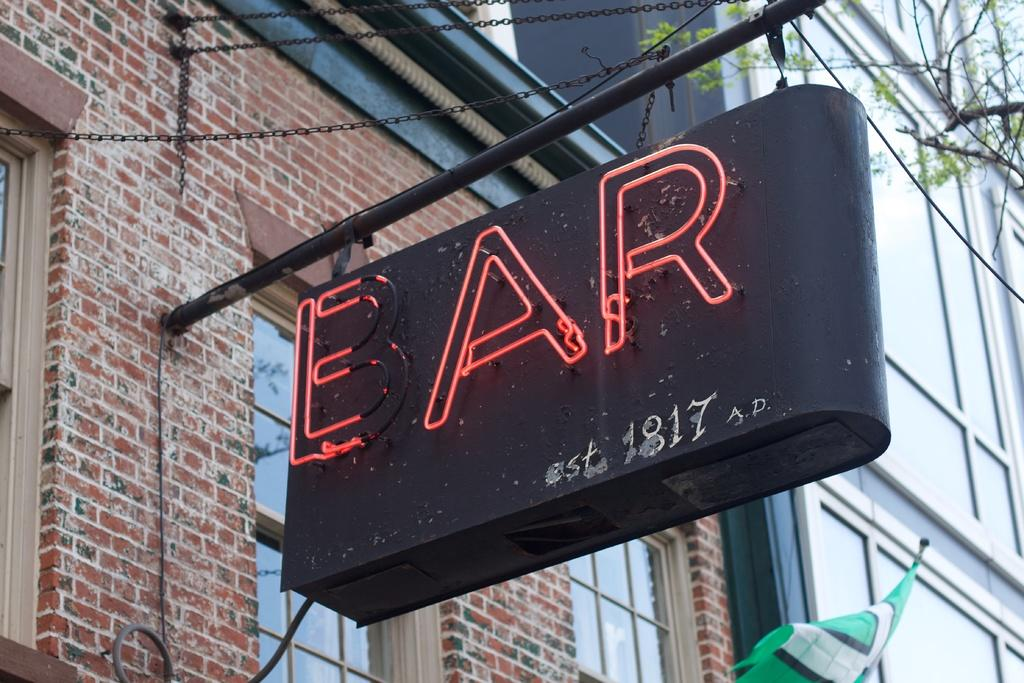What type of structure is visible in the image? There is a building in the image. What feature can be seen on the building? The building has windows. What word is written on the board in the image? The word "bar" is written on the board in the image. What type of plant is present in the image? There is a tree in the image. What color is the cloth in the image? The cloth in the image is green. How many people are in the crowd gathered around the building in the image? There is no crowd present in the image; it only shows the building, a board with the word "bar," a tree, and a green cloth. 